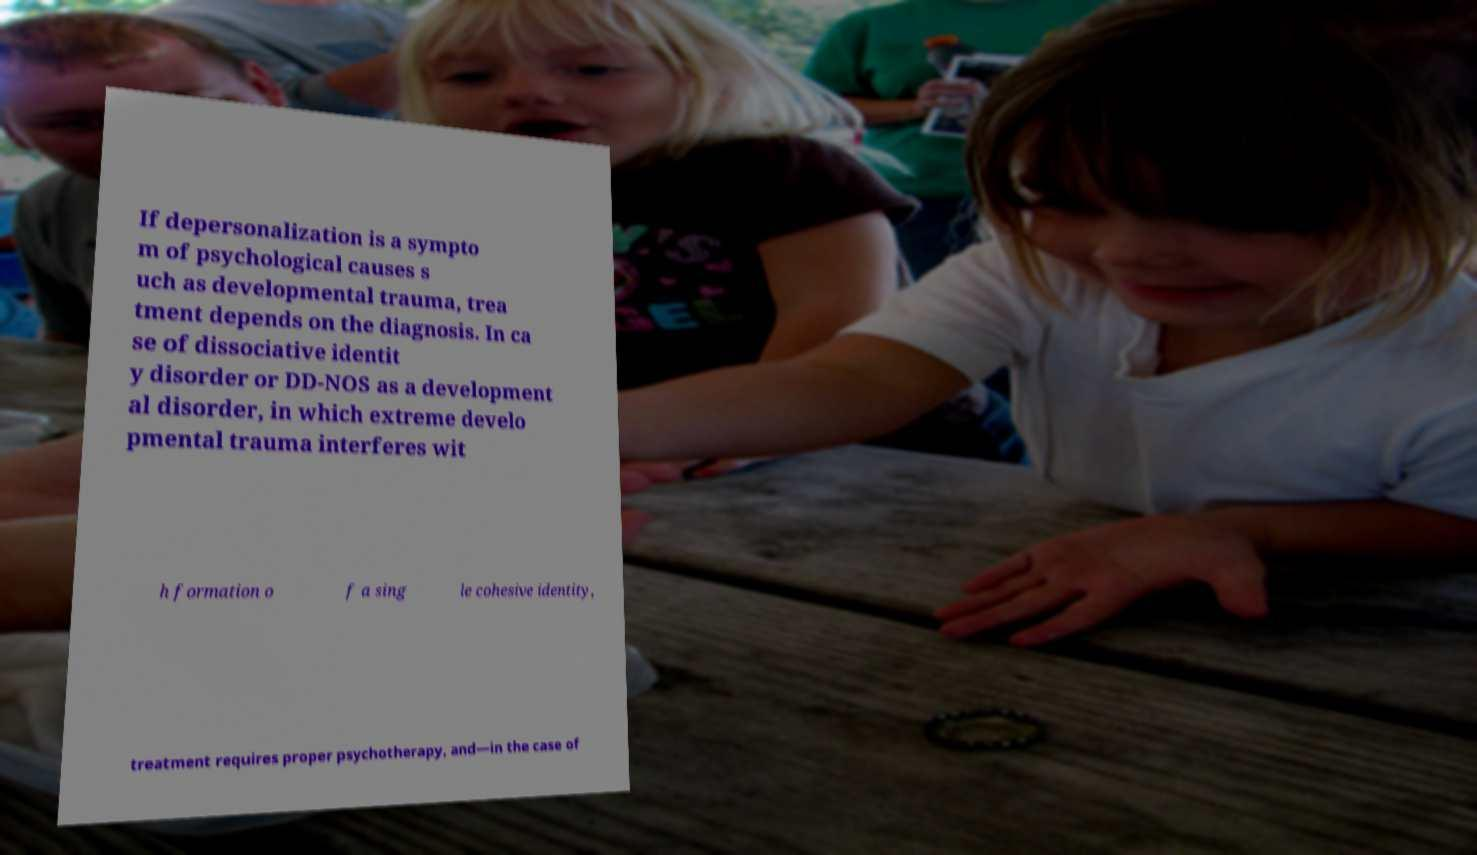Please read and relay the text visible in this image. What does it say? If depersonalization is a sympto m of psychological causes s uch as developmental trauma, trea tment depends on the diagnosis. In ca se of dissociative identit y disorder or DD-NOS as a development al disorder, in which extreme develo pmental trauma interferes wit h formation o f a sing le cohesive identity, treatment requires proper psychotherapy, and—in the case of 